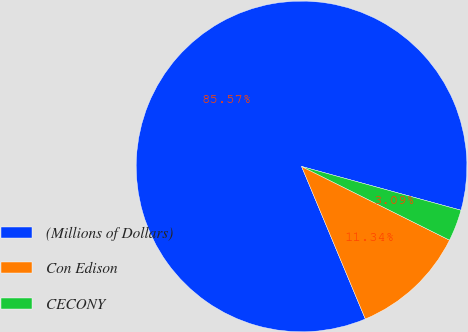Convert chart to OTSL. <chart><loc_0><loc_0><loc_500><loc_500><pie_chart><fcel>(Millions of Dollars)<fcel>Con Edison<fcel>CECONY<nl><fcel>85.57%<fcel>11.34%<fcel>3.09%<nl></chart> 